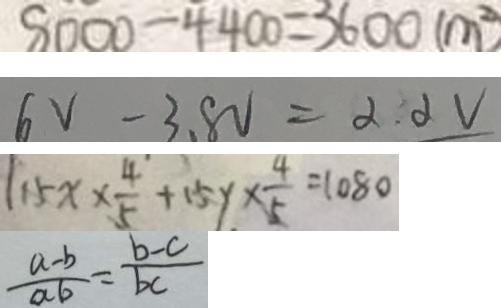<formula> <loc_0><loc_0><loc_500><loc_500>8 0 0 0 - 4 4 0 0 = 3 6 0 0 ( m ^ { 2 } ) 
 6 V - 3 . 8 V = 2 . 2 V 
 1 1 5 x \times \frac { 4 } { 5 } + 1 5 y \times \frac { 4 } { 5 } = 1 0 8 0 
 \frac { a - b } { a b } = \frac { b - c } { b c }</formula> 